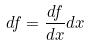<formula> <loc_0><loc_0><loc_500><loc_500>d f = \frac { d f } { d x } d x</formula> 